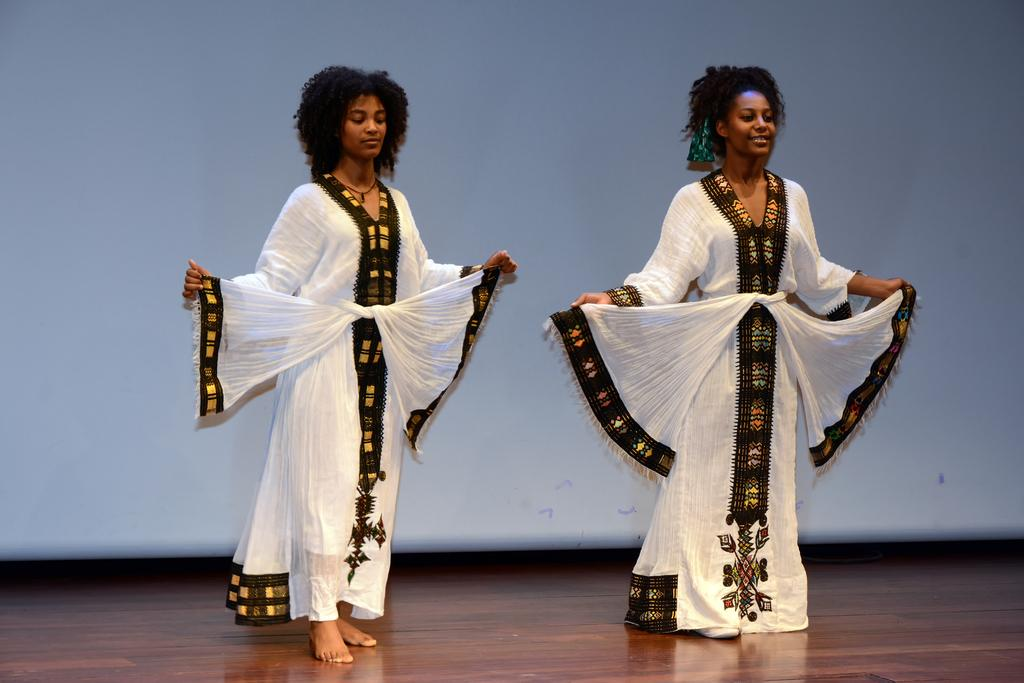How many people are in the image? There are two people in the image. What colors are the dresses worn by the people? One person is wearing a cream-colored dress, and the other person is wearing a white-colored dress. What color is the dress worn by the third person? There is no third person mentioned in the facts, but there is a person wearing a black-colored dress. What type of surface are the people standing on? The people are standing on a wooden surface. What color is the background of the image? The background of the image is white. What type of list can be seen in the image? There is no list present in the image. How does the sleet affect the people in the image? There is no mention of sleet or any weather conditions in the image. 